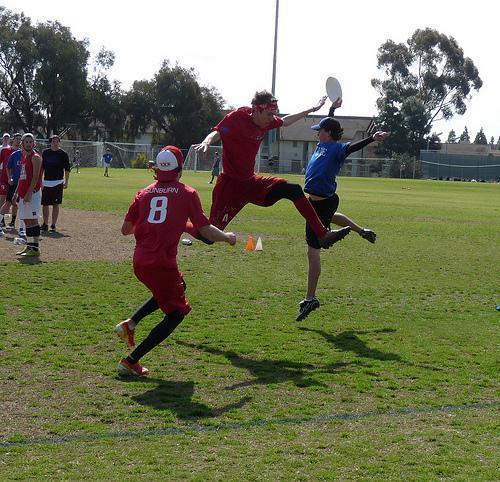How many cones are on the field?
Give a very brief answer. 2. How many people are not touching the ground?
Give a very brief answer. 2. How many players are wearing red uniforms?
Give a very brief answer. 2. How many players are in the center of the photo?
Give a very brief answer. 3. How many full body shadows are present?
Give a very brief answer. 3. How many people are looking at the boys play Frisbee?
Give a very brief answer. 4. How many players are wearing red shirts?
Give a very brief answer. 2. How many boys are wearing a black shirt?
Give a very brief answer. 1. 